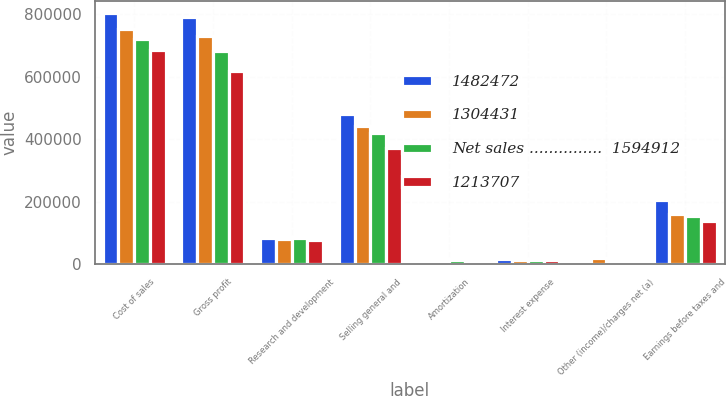Convert chart. <chart><loc_0><loc_0><loc_500><loc_500><stacked_bar_chart><ecel><fcel>Cost of sales<fcel>Gross profit<fcel>Research and development<fcel>Selling general and<fcel>Amortization<fcel>Interest expense<fcel>Other (income)/charges net (a)<fcel>Earnings before taxes and<nl><fcel>1482472<fcel>804480<fcel>790432<fcel>82802<fcel>481709<fcel>11503<fcel>17492<fcel>7921<fcel>204847<nl><fcel>1304431<fcel>752153<fcel>730319<fcel>81893<fcel>441702<fcel>11436<fcel>14880<fcel>20224<fcel>160184<nl><fcel>Net sales ...............  1594912<fcel>722047<fcel>682407<fcel>83217<fcel>419780<fcel>12256<fcel>12888<fcel>42<fcel>154224<nl><fcel>1213707<fcel>686255<fcel>618176<fcel>78003<fcel>372822<fcel>11724<fcel>14153<fcel>4563<fcel>136911<nl></chart> 